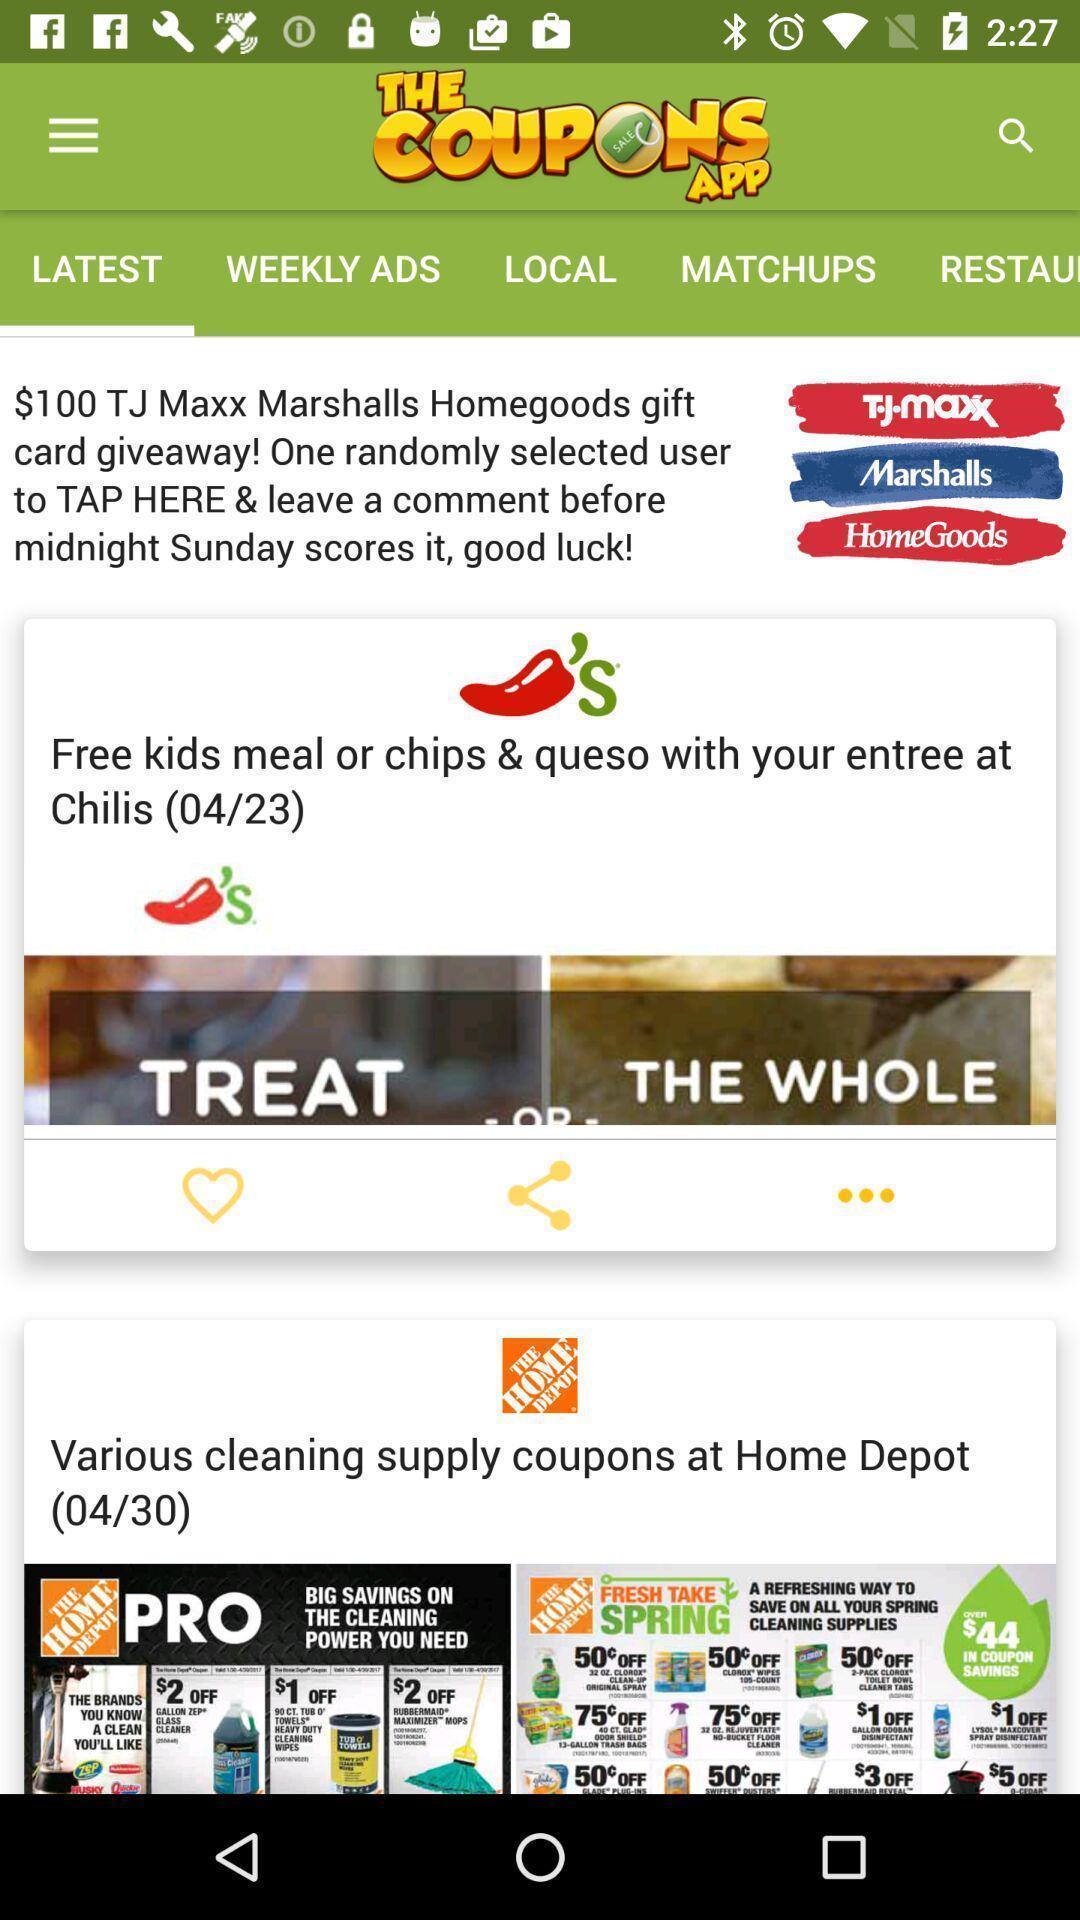Provide a detailed account of this screenshot. Screen shows multiple options in a shopping application. 